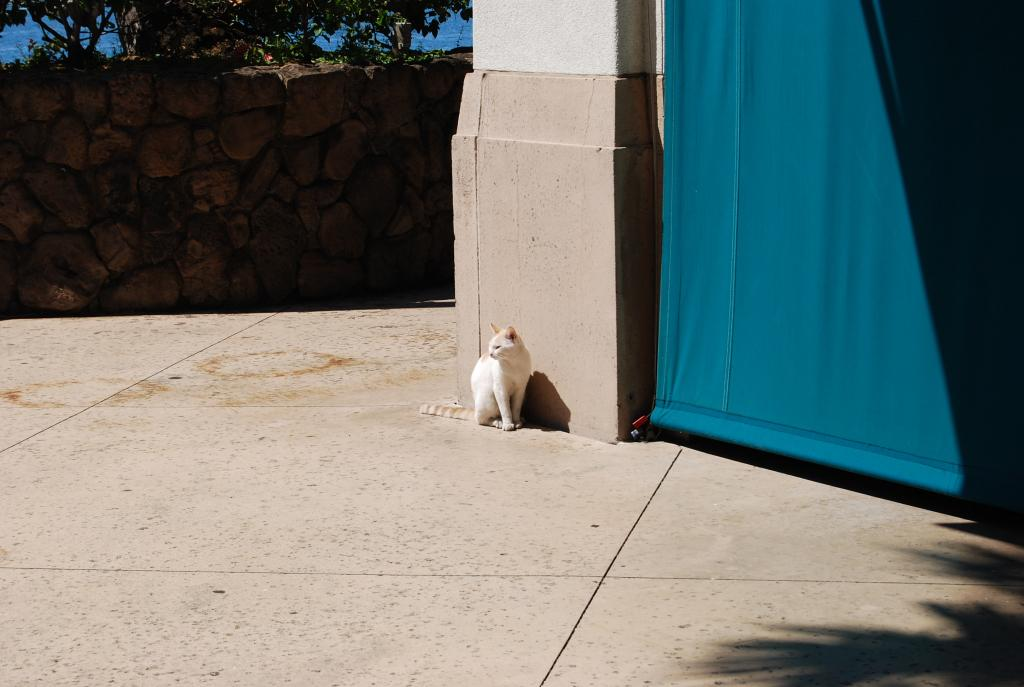What is the main subject in the center of the image? There is a cat in the center of the image. What can be seen on the right side of the image? There is a curtain on the right side of the image. What is located on the left side of the image? There is a wall on the left side of the image. What type of vegetation is visible on the left side of the image? There are trees visible on the left side of the image. Where is the cook standing in the image? There is no cook present in the image. What type of kite can be seen flying in the image? There is no kite present in the image. 